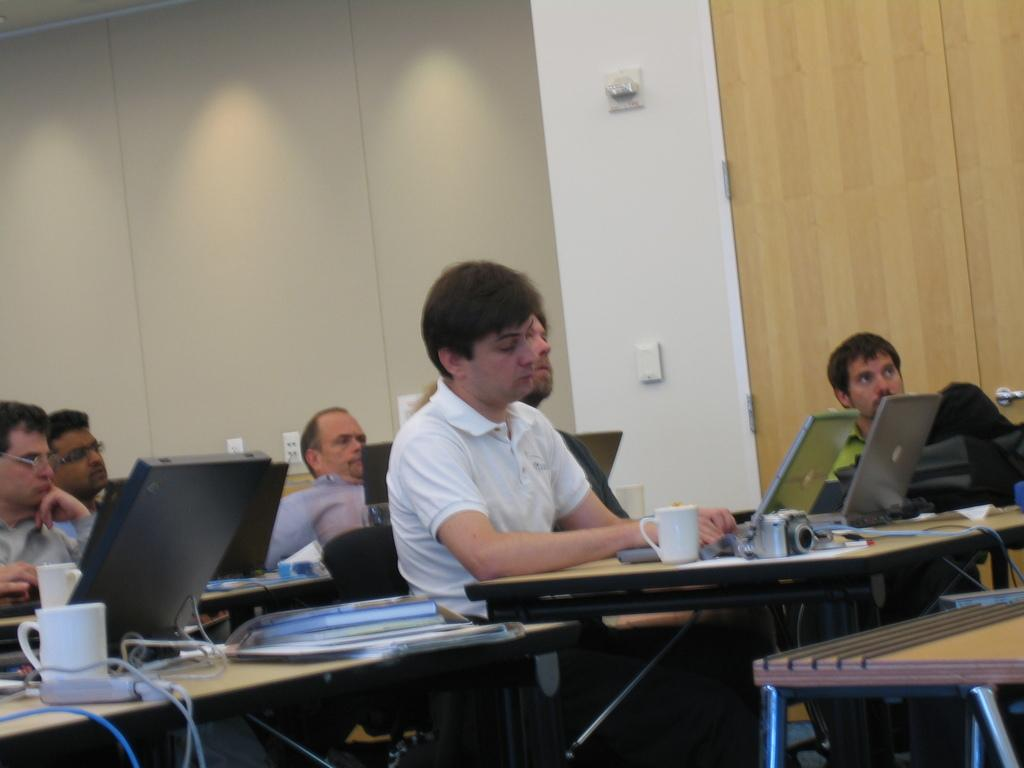What are the people in the image doing? There is a group of people sitting on chairs in the image. What can be seen on the table in the image? There is a cup, a laptop, and a camera on the table in the image. What type of bread is being used to tell a story in the image? There is no bread present in the image, and no storytelling is taking place. 